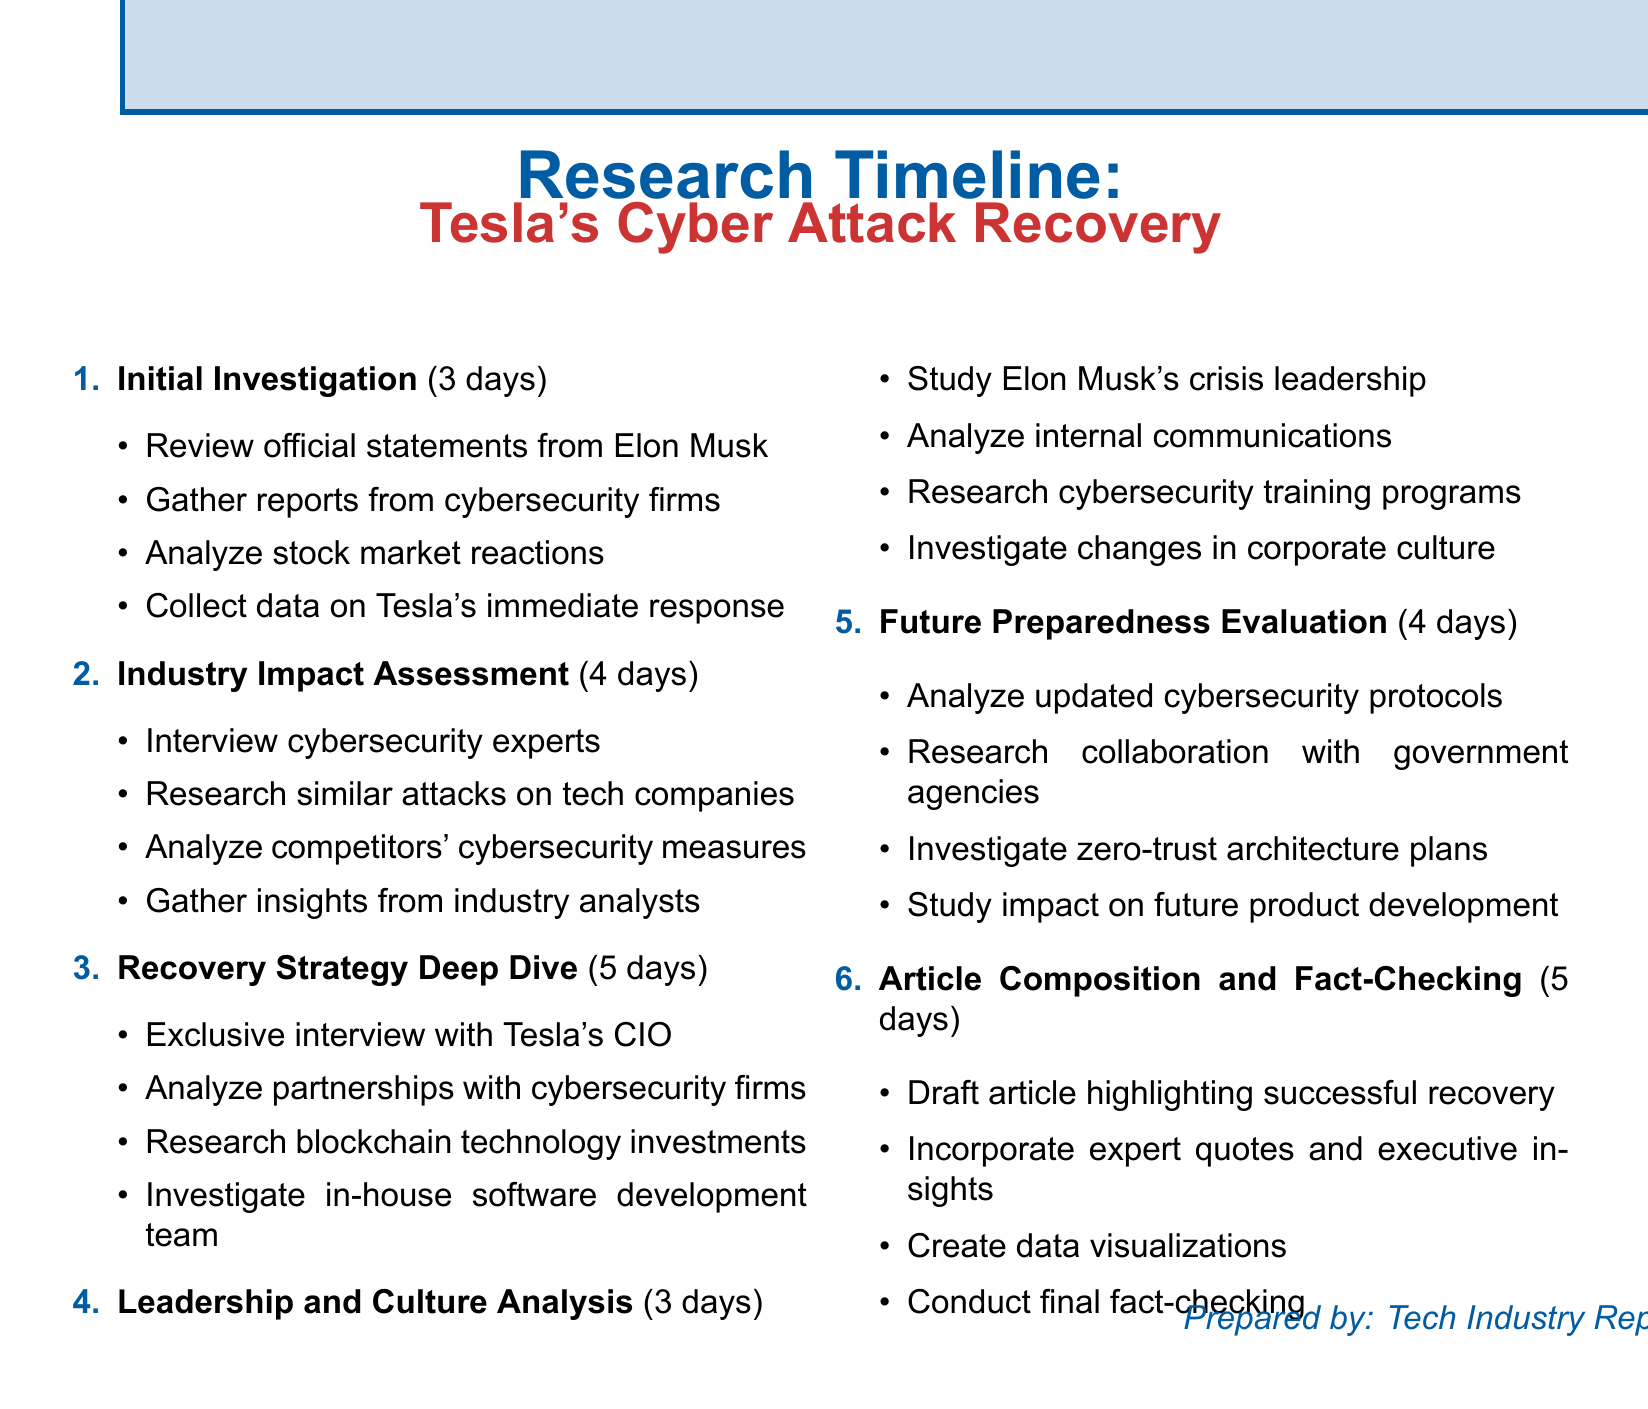What is the duration of the Initial Investigation phase? The duration of the Initial Investigation phase is stated in the document as 3 days.
Answer: 3 days Who is the CIO of Tesla interviewed during the Recovery Strategy Deep Dive? The document mentions conducting an exclusive interview with Tesla's CIO, though it does not specify their name.
Answer: Tesla's CIO How many days does the Future Preparedness Evaluation phase take? The document specifies that the Future Preparedness Evaluation phase lasts for 4 days.
Answer: 4 days What is one task conducted during the Industry Impact Assessment phase? The document lists several tasks, one of which is interviewing cybersecurity experts.
Answer: Interview cybersecurity experts Which cybersecurity firm is mentioned in relation to Tesla's partnerships? The document references Darktrace as the cybersecurity firm Tesla partners with for threat detection.
Answer: Darktrace How many phases are in the research timeline? The document outlines a total of six phases in the research timeline.
Answer: Six What change in corporate practices is researched in the Leadership and Culture Analysis phase? The document mentions investigating changes in Tesla's corporate culture post-attack.
Answer: Corporate culture What type of investment is Tesla being evaluated for in the Recovery Strategy Deep Dive? The document states that the evaluation includes researching Tesla's investment in blockchain technology.
Answer: Blockchain technology 